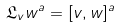<formula> <loc_0><loc_0><loc_500><loc_500>\mathfrak { L } _ { v } w ^ { a } = [ v , w ] ^ { a }</formula> 